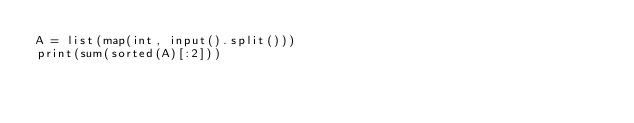<code> <loc_0><loc_0><loc_500><loc_500><_Python_>A = list(map(int, input().split()))
print(sum(sorted(A)[:2]))</code> 